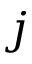Convert formula to latex. <formula><loc_0><loc_0><loc_500><loc_500>j</formula> 